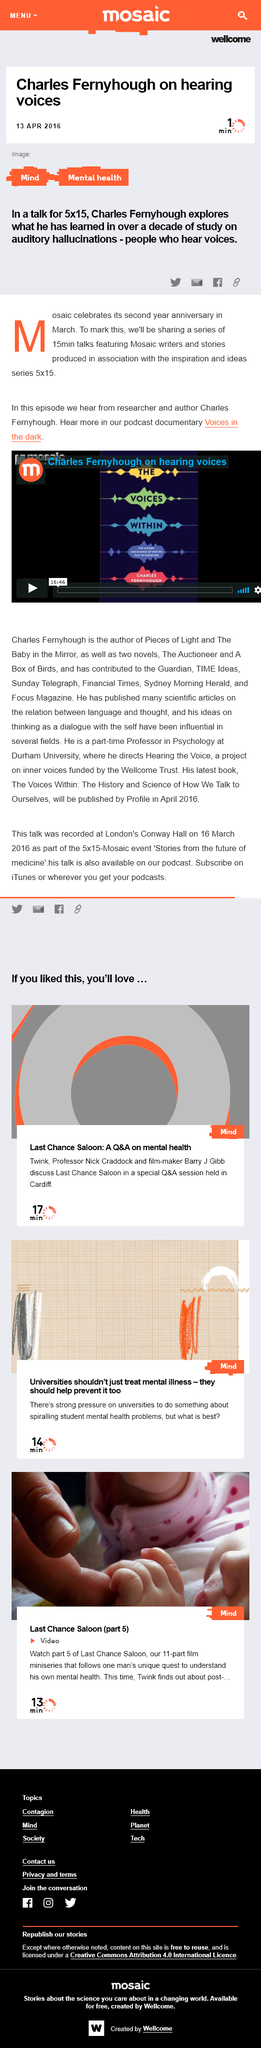Outline some significant characteristics in this image. It has been announced that Charles Fernyhough will be giving a talk on hearing voices. Mosaic is celebrating its second anniversary in March, having been founded exactly two years ago. Mosaic's talks are 15 minutes long, and they are shared for how long? 